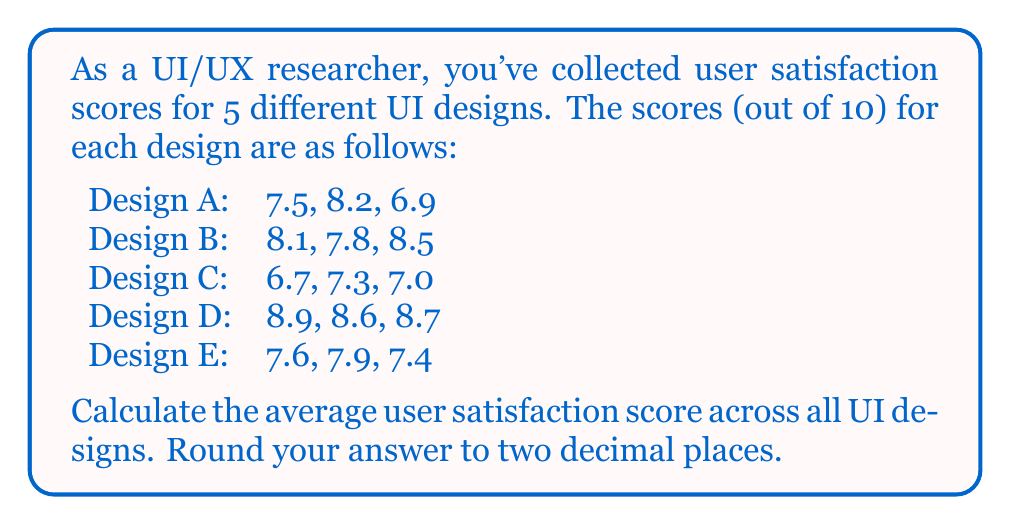Give your solution to this math problem. To solve this problem, we'll follow these steps:

1. Calculate the average score for each design:

   Design A: $\frac{7.5 + 8.2 + 6.9}{3} = 7.53333...$
   Design B: $\frac{8.1 + 7.8 + 8.5}{3} = 8.13333...$
   Design C: $\frac{6.7 + 7.3 + 7.0}{3} = 7.00000...$
   Design D: $\frac{8.9 + 8.6 + 8.7}{3} = 8.73333...$
   Design E: $\frac{7.6 + 7.9 + 7.4}{3} = 7.63333...$

2. Calculate the average of these averages:

   $$\text{Overall Average} = \frac{\text{Sum of Averages}}{\text{Number of Designs}}$$

   $$\text{Overall Average} = \frac{7.53333... + 8.13333... + 7.00000... + 8.73333... + 7.63333...}{5}$$

3. Simplify:

   $$\text{Overall Average} = \frac{39.03333...}{5} = 7.80666...$$

4. Round to two decimal places:

   $$\text{Overall Average} \approx 7.81$$
Answer: 7.81 